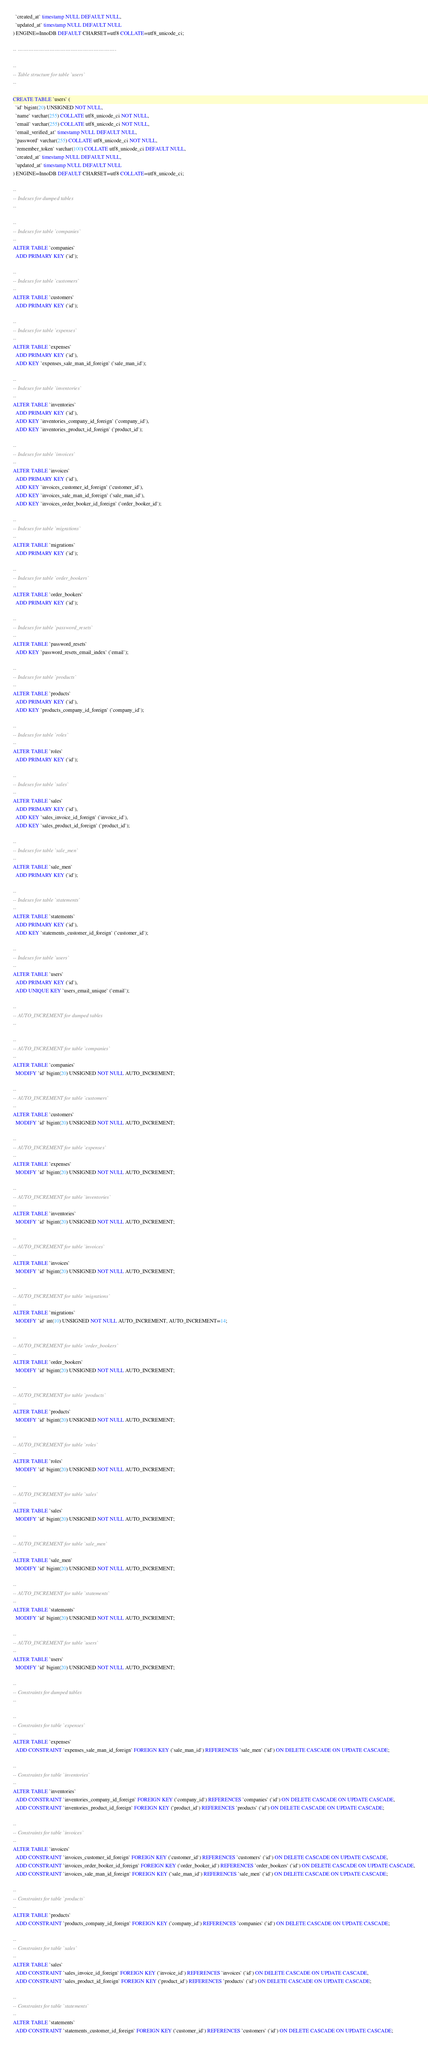<code> <loc_0><loc_0><loc_500><loc_500><_SQL_>  `created_at` timestamp NULL DEFAULT NULL,
  `updated_at` timestamp NULL DEFAULT NULL
) ENGINE=InnoDB DEFAULT CHARSET=utf8 COLLATE=utf8_unicode_ci;

-- --------------------------------------------------------

--
-- Table structure for table `users`
--

CREATE TABLE `users` (
  `id` bigint(20) UNSIGNED NOT NULL,
  `name` varchar(255) COLLATE utf8_unicode_ci NOT NULL,
  `email` varchar(255) COLLATE utf8_unicode_ci NOT NULL,
  `email_verified_at` timestamp NULL DEFAULT NULL,
  `password` varchar(255) COLLATE utf8_unicode_ci NOT NULL,
  `remember_token` varchar(100) COLLATE utf8_unicode_ci DEFAULT NULL,
  `created_at` timestamp NULL DEFAULT NULL,
  `updated_at` timestamp NULL DEFAULT NULL
) ENGINE=InnoDB DEFAULT CHARSET=utf8 COLLATE=utf8_unicode_ci;

--
-- Indexes for dumped tables
--

--
-- Indexes for table `companies`
--
ALTER TABLE `companies`
  ADD PRIMARY KEY (`id`);

--
-- Indexes for table `customers`
--
ALTER TABLE `customers`
  ADD PRIMARY KEY (`id`);

--
-- Indexes for table `expenses`
--
ALTER TABLE `expenses`
  ADD PRIMARY KEY (`id`),
  ADD KEY `expenses_sale_man_id_foreign` (`sale_man_id`);

--
-- Indexes for table `inventories`
--
ALTER TABLE `inventories`
  ADD PRIMARY KEY (`id`),
  ADD KEY `inventories_company_id_foreign` (`company_id`),
  ADD KEY `inventories_product_id_foreign` (`product_id`);

--
-- Indexes for table `invoices`
--
ALTER TABLE `invoices`
  ADD PRIMARY KEY (`id`),
  ADD KEY `invoices_customer_id_foreign` (`customer_id`),
  ADD KEY `invoices_sale_man_id_foreign` (`sale_man_id`),
  ADD KEY `invoices_order_booker_id_foreign` (`order_booker_id`);

--
-- Indexes for table `migrations`
--
ALTER TABLE `migrations`
  ADD PRIMARY KEY (`id`);

--
-- Indexes for table `order_bookers`
--
ALTER TABLE `order_bookers`
  ADD PRIMARY KEY (`id`);

--
-- Indexes for table `password_resets`
--
ALTER TABLE `password_resets`
  ADD KEY `password_resets_email_index` (`email`);

--
-- Indexes for table `products`
--
ALTER TABLE `products`
  ADD PRIMARY KEY (`id`),
  ADD KEY `products_company_id_foreign` (`company_id`);

--
-- Indexes for table `roles`
--
ALTER TABLE `roles`
  ADD PRIMARY KEY (`id`);

--
-- Indexes for table `sales`
--
ALTER TABLE `sales`
  ADD PRIMARY KEY (`id`),
  ADD KEY `sales_invoice_id_foreign` (`invoice_id`),
  ADD KEY `sales_product_id_foreign` (`product_id`);

--
-- Indexes for table `sale_men`
--
ALTER TABLE `sale_men`
  ADD PRIMARY KEY (`id`);

--
-- Indexes for table `statements`
--
ALTER TABLE `statements`
  ADD PRIMARY KEY (`id`),
  ADD KEY `statements_customer_id_foreign` (`customer_id`);

--
-- Indexes for table `users`
--
ALTER TABLE `users`
  ADD PRIMARY KEY (`id`),
  ADD UNIQUE KEY `users_email_unique` (`email`);

--
-- AUTO_INCREMENT for dumped tables
--

--
-- AUTO_INCREMENT for table `companies`
--
ALTER TABLE `companies`
  MODIFY `id` bigint(20) UNSIGNED NOT NULL AUTO_INCREMENT;

--
-- AUTO_INCREMENT for table `customers`
--
ALTER TABLE `customers`
  MODIFY `id` bigint(20) UNSIGNED NOT NULL AUTO_INCREMENT;

--
-- AUTO_INCREMENT for table `expenses`
--
ALTER TABLE `expenses`
  MODIFY `id` bigint(20) UNSIGNED NOT NULL AUTO_INCREMENT;

--
-- AUTO_INCREMENT for table `inventories`
--
ALTER TABLE `inventories`
  MODIFY `id` bigint(20) UNSIGNED NOT NULL AUTO_INCREMENT;

--
-- AUTO_INCREMENT for table `invoices`
--
ALTER TABLE `invoices`
  MODIFY `id` bigint(20) UNSIGNED NOT NULL AUTO_INCREMENT;

--
-- AUTO_INCREMENT for table `migrations`
--
ALTER TABLE `migrations`
  MODIFY `id` int(10) UNSIGNED NOT NULL AUTO_INCREMENT, AUTO_INCREMENT=14;

--
-- AUTO_INCREMENT for table `order_bookers`
--
ALTER TABLE `order_bookers`
  MODIFY `id` bigint(20) UNSIGNED NOT NULL AUTO_INCREMENT;

--
-- AUTO_INCREMENT for table `products`
--
ALTER TABLE `products`
  MODIFY `id` bigint(20) UNSIGNED NOT NULL AUTO_INCREMENT;

--
-- AUTO_INCREMENT for table `roles`
--
ALTER TABLE `roles`
  MODIFY `id` bigint(20) UNSIGNED NOT NULL AUTO_INCREMENT;

--
-- AUTO_INCREMENT for table `sales`
--
ALTER TABLE `sales`
  MODIFY `id` bigint(20) UNSIGNED NOT NULL AUTO_INCREMENT;

--
-- AUTO_INCREMENT for table `sale_men`
--
ALTER TABLE `sale_men`
  MODIFY `id` bigint(20) UNSIGNED NOT NULL AUTO_INCREMENT;

--
-- AUTO_INCREMENT for table `statements`
--
ALTER TABLE `statements`
  MODIFY `id` bigint(20) UNSIGNED NOT NULL AUTO_INCREMENT;

--
-- AUTO_INCREMENT for table `users`
--
ALTER TABLE `users`
  MODIFY `id` bigint(20) UNSIGNED NOT NULL AUTO_INCREMENT;

--
-- Constraints for dumped tables
--

--
-- Constraints for table `expenses`
--
ALTER TABLE `expenses`
  ADD CONSTRAINT `expenses_sale_man_id_foreign` FOREIGN KEY (`sale_man_id`) REFERENCES `sale_men` (`id`) ON DELETE CASCADE ON UPDATE CASCADE;

--
-- Constraints for table `inventories`
--
ALTER TABLE `inventories`
  ADD CONSTRAINT `inventories_company_id_foreign` FOREIGN KEY (`company_id`) REFERENCES `companies` (`id`) ON DELETE CASCADE ON UPDATE CASCADE,
  ADD CONSTRAINT `inventories_product_id_foreign` FOREIGN KEY (`product_id`) REFERENCES `products` (`id`) ON DELETE CASCADE ON UPDATE CASCADE;

--
-- Constraints for table `invoices`
--
ALTER TABLE `invoices`
  ADD CONSTRAINT `invoices_customer_id_foreign` FOREIGN KEY (`customer_id`) REFERENCES `customers` (`id`) ON DELETE CASCADE ON UPDATE CASCADE,
  ADD CONSTRAINT `invoices_order_booker_id_foreign` FOREIGN KEY (`order_booker_id`) REFERENCES `order_bookers` (`id`) ON DELETE CASCADE ON UPDATE CASCADE,
  ADD CONSTRAINT `invoices_sale_man_id_foreign` FOREIGN KEY (`sale_man_id`) REFERENCES `sale_men` (`id`) ON DELETE CASCADE ON UPDATE CASCADE;

--
-- Constraints for table `products`
--
ALTER TABLE `products`
  ADD CONSTRAINT `products_company_id_foreign` FOREIGN KEY (`company_id`) REFERENCES `companies` (`id`) ON DELETE CASCADE ON UPDATE CASCADE;

--
-- Constraints for table `sales`
--
ALTER TABLE `sales`
  ADD CONSTRAINT `sales_invoice_id_foreign` FOREIGN KEY (`invoice_id`) REFERENCES `invoices` (`id`) ON DELETE CASCADE ON UPDATE CASCADE,
  ADD CONSTRAINT `sales_product_id_foreign` FOREIGN KEY (`product_id`) REFERENCES `products` (`id`) ON DELETE CASCADE ON UPDATE CASCADE;

--
-- Constraints for table `statements`
--
ALTER TABLE `statements`
  ADD CONSTRAINT `statements_customer_id_foreign` FOREIGN KEY (`customer_id`) REFERENCES `customers` (`id`) ON DELETE CASCADE ON UPDATE CASCADE;
</code> 